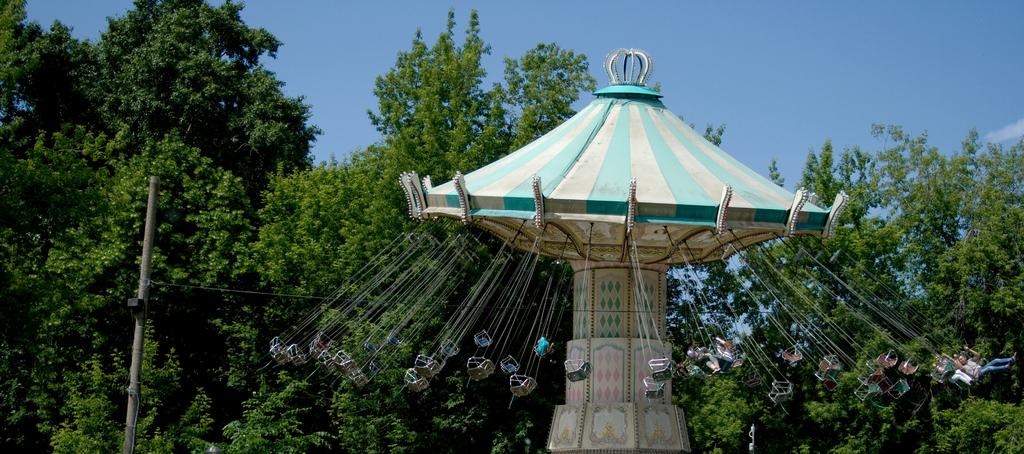What is the main object in the center of the image? There is a "playing thing" thing" (possibly a playground equipment or a toy) in the center of the image. What else can be seen in the image besides the main object? There is a pole and wire in the image. What can be seen in the background of the image? There are trees and the sky visible in the background of the image. How many worms can be seen crawling on the "playing thing" in the image? There are no worms visible in the image; it features a "playing thing," pole, wire, trees, and the sky. What idea does the image represent? The image does not represent a specific idea; it is a visual representation of the objects mentioned in the facts. 